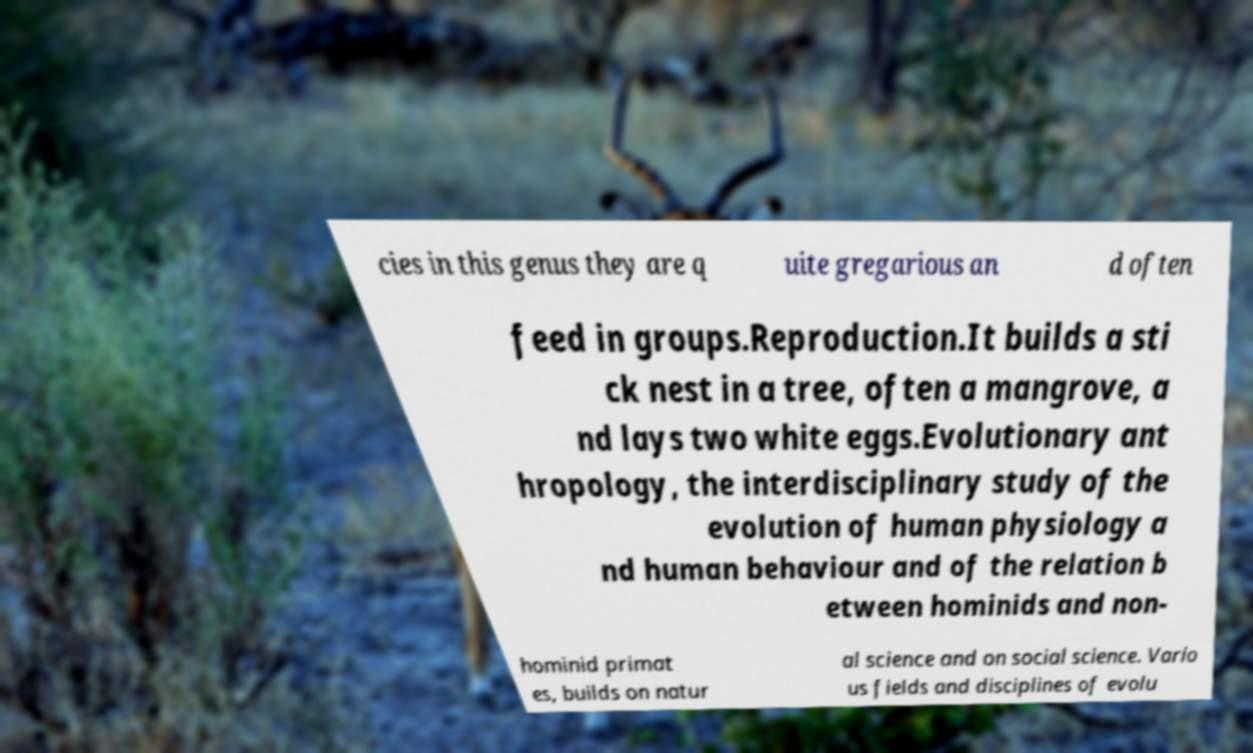Can you accurately transcribe the text from the provided image for me? cies in this genus they are q uite gregarious an d often feed in groups.Reproduction.It builds a sti ck nest in a tree, often a mangrove, a nd lays two white eggs.Evolutionary ant hropology, the interdisciplinary study of the evolution of human physiology a nd human behaviour and of the relation b etween hominids and non- hominid primat es, builds on natur al science and on social science. Vario us fields and disciplines of evolu 